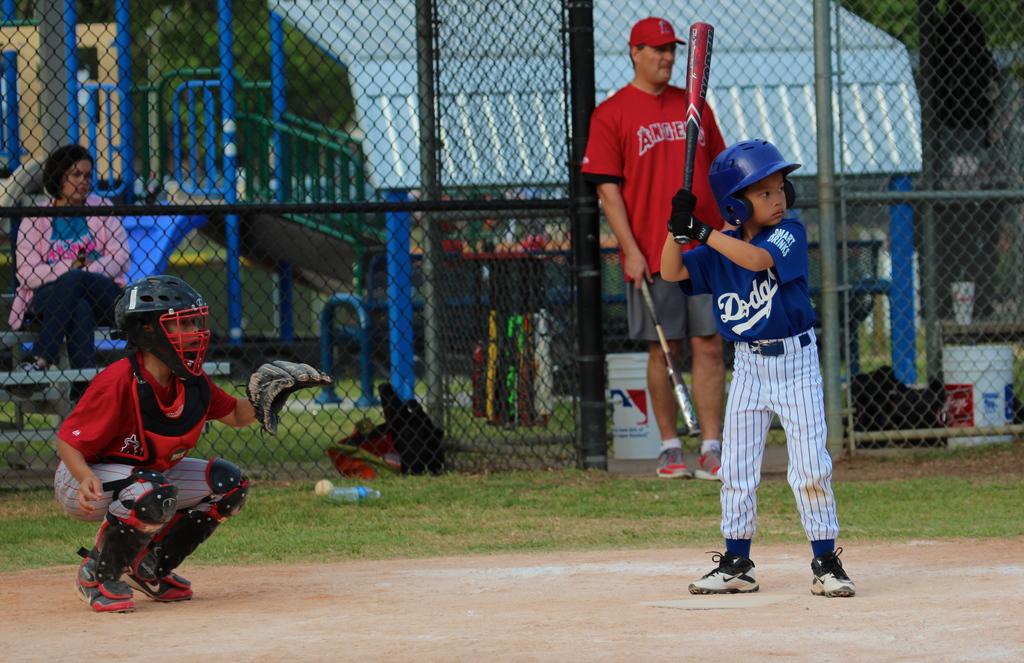What is the team in the red jersey?
Your response must be concise. Angels. 